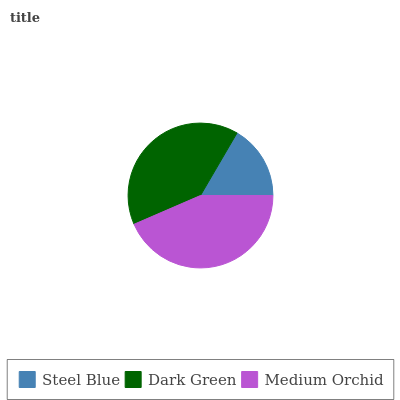Is Steel Blue the minimum?
Answer yes or no. Yes. Is Medium Orchid the maximum?
Answer yes or no. Yes. Is Dark Green the minimum?
Answer yes or no. No. Is Dark Green the maximum?
Answer yes or no. No. Is Dark Green greater than Steel Blue?
Answer yes or no. Yes. Is Steel Blue less than Dark Green?
Answer yes or no. Yes. Is Steel Blue greater than Dark Green?
Answer yes or no. No. Is Dark Green less than Steel Blue?
Answer yes or no. No. Is Dark Green the high median?
Answer yes or no. Yes. Is Dark Green the low median?
Answer yes or no. Yes. Is Medium Orchid the high median?
Answer yes or no. No. Is Medium Orchid the low median?
Answer yes or no. No. 